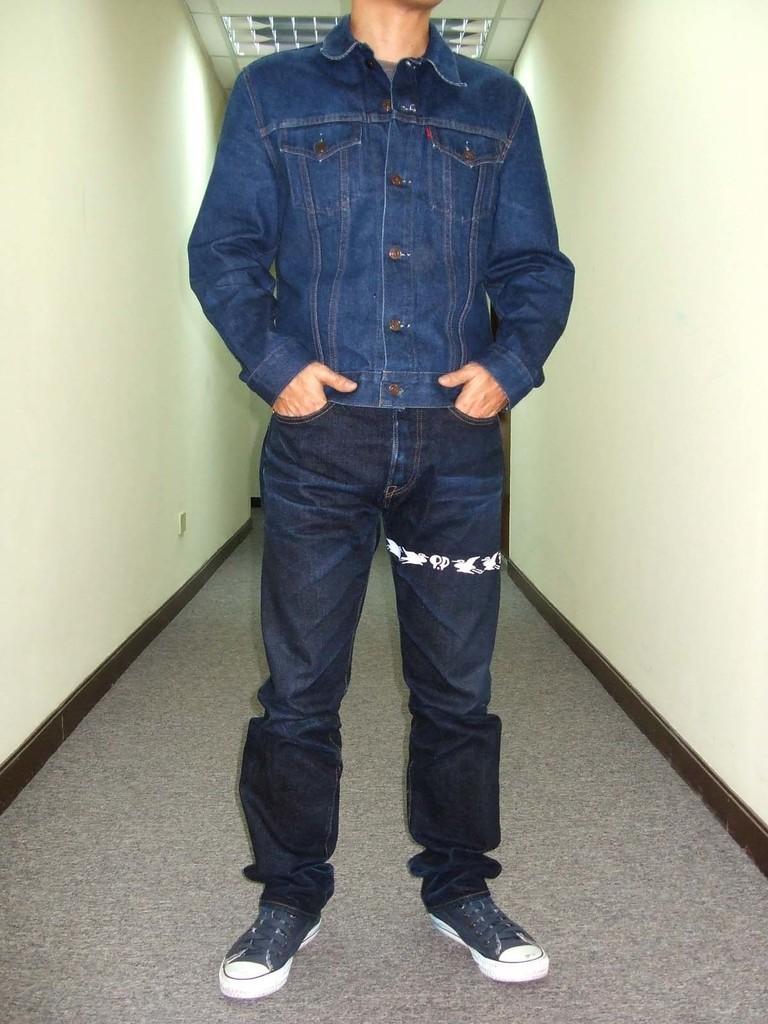Can you describe this image briefly? In the foreground there is a person standing on floor. On the left it is well. On the right it is well. At the top we can see light to the ceiling. 